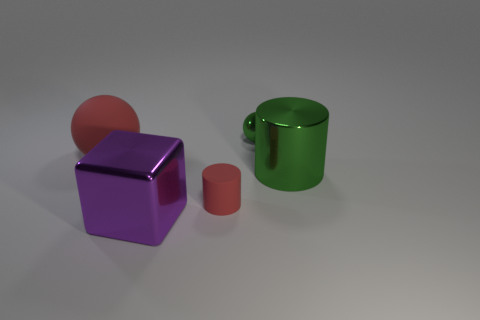Subtract all purple spheres. Subtract all cyan cylinders. How many spheres are left? 2 Add 2 metallic cylinders. How many objects exist? 7 Subtract all cylinders. How many objects are left? 3 Subtract 1 green cylinders. How many objects are left? 4 Subtract all shiny cylinders. Subtract all shiny spheres. How many objects are left? 3 Add 4 big green cylinders. How many big green cylinders are left? 5 Add 4 large purple blocks. How many large purple blocks exist? 5 